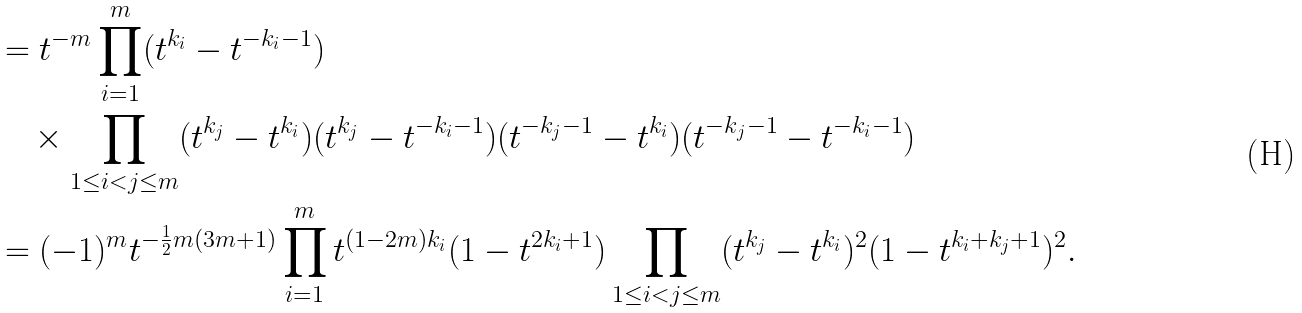Convert formula to latex. <formula><loc_0><loc_0><loc_500><loc_500>& = t ^ { - m } \prod _ { i = 1 } ^ { m } ( t ^ { k _ { i } } - t ^ { - k _ { i } - 1 } ) \\ & \quad \times \prod _ { 1 \leq i < j \leq m } ( t ^ { k _ { j } } - t ^ { k _ { i } } ) ( t ^ { k _ { j } } - t ^ { - k _ { i } - 1 } ) ( t ^ { - k _ { j } - 1 } - t ^ { k _ { i } } ) ( t ^ { - k _ { j } - 1 } - t ^ { - k _ { i } - 1 } ) \\ & = ( - 1 ) ^ { m } t ^ { - \frac { 1 } { 2 } m ( 3 m + 1 ) } \prod _ { i = 1 } ^ { m } t ^ { ( 1 - 2 m ) k _ { i } } ( 1 - t ^ { 2 k _ { i } + 1 } ) \prod _ { 1 \leq i < j \leq m } ( t ^ { k _ { j } } - t ^ { k _ { i } } ) ^ { 2 } ( 1 - t ^ { k _ { i } + k _ { j } + 1 } ) ^ { 2 } .</formula> 